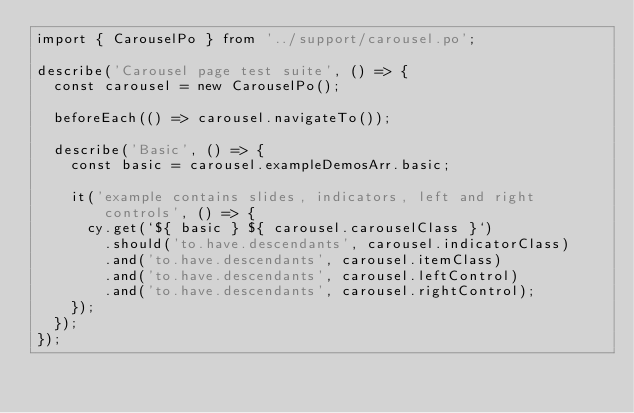Convert code to text. <code><loc_0><loc_0><loc_500><loc_500><_TypeScript_>import { CarouselPo } from '../support/carousel.po';

describe('Carousel page test suite', () => {
  const carousel = new CarouselPo();

  beforeEach(() => carousel.navigateTo());

  describe('Basic', () => {
    const basic = carousel.exampleDemosArr.basic;

    it('example contains slides, indicators, left and right controls', () => {
      cy.get(`${ basic } ${ carousel.carouselClass }`)
        .should('to.have.descendants', carousel.indicatorClass)
        .and('to.have.descendants', carousel.itemClass)
        .and('to.have.descendants', carousel.leftControl)
        .and('to.have.descendants', carousel.rightControl);
    });
  });
});
</code> 